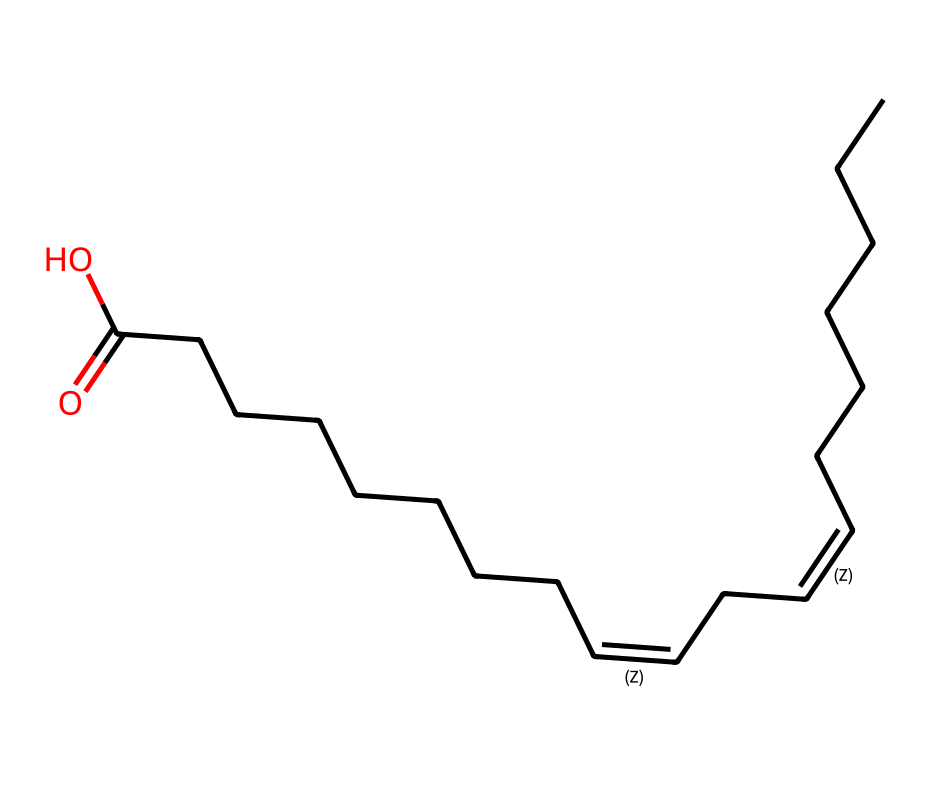What is the type of fatty acid represented by this structure? The structure includes multiple cis and trans double bonds, typical for unsaturated fatty acids; therefore, it is classified as a polyunsaturated fatty acid.
Answer: polyunsaturated fatty acid How many double bonds are present in linoleic acid? By examining the structure, there are two double bonds between carbon atoms indicated in the SMILES notation by '/C=C\' symbols.
Answer: two What is the total number of carbon atoms in linoleic acid? The structure indicates a long hydrocarbon chain where carbon atoms are packed, and counting all carbon atoms in the SMILES string gives a total of eighteen.
Answer: eighteen What are the geometric isomers of linoleic acid based on its structure? In the case of linoleic acid, the two double bonds can exist in cis or trans configurations, resulting in cis-cis, trans-cis, and possibly trans-trans isomers.
Answer: cis-cis, trans-cis, trans-trans Which part of linoleic acid contributes to its geometric isomerism? The presence of the two double bonds allows for various spatial arrangements of the hydrogen atoms attached to the carbon atoms involved in the double bonds, leading to geometric isomerism.
Answer: double bonds What functional group is found at the end of the linoleic acid molecule? The structure indicates a carboxylic acid group (-COOH) at the end of the fatty acid chain, as seen in the final part of the SMILES representation.
Answer: carboxylic acid 